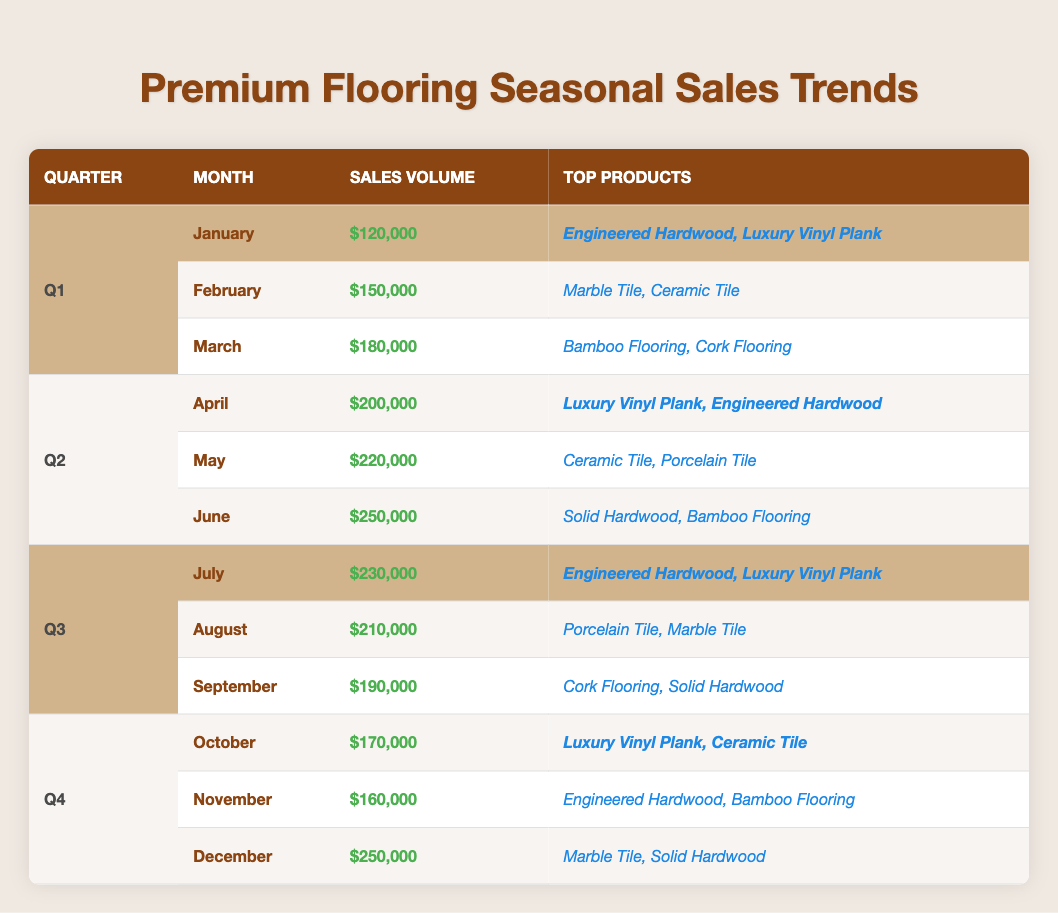What was the sales volume in June? The sales volume listed for June is $250,000, as shown directly in the table under Q2 for the month of June.
Answer: $250,000 Which month had the highest sales volume in Q1? By comparing the sales volumes of January ($120,000), February ($150,000), and March ($180,000), March has the highest sales volume of $180,000.
Answer: March What are the top products sold in October? The top products listed for October are Luxury Vinyl Plank and Ceramic Tile, as seen in the table for Q4 in the month of October.
Answer: Luxury Vinyl Plank, Ceramic Tile What is the total sales volume for Q3? Summing the sales volumes for July ($230,000), August ($210,000), and September ($190,000) gives a total of $230,000 + $210,000 + $190,000 = $630,000 for Q3.
Answer: $630,000 Were Engineered Hardwood products sold in every quarter? Looking at the top products for each quarter: Q1 has it, Q2 has it, Q3 has it, and Q4 has it too, confirming that Engineered Hardwood is present in all quarters.
Answer: Yes What was the average sales volume across all months in Q2? The sales volumes for Q2 are April ($200,000), May ($220,000), and June ($250,000). Adding these gives $200,000 + $220,000 + $250,000 = $670,000. Dividing by 3 months gives an average of $670,000 / 3 = $223,333.33, which rounds to $223,333.
Answer: $223,333 Which quarter had the highest total sales volume overall? Calculating total sales volumes: Q1 = $450,000 ($120,000 + $150,000 + $180,000), Q2 = $670,000 ($200,000 + $220,000 + $250,000), Q3 = $630,000 ($230,000 + $210,000 + $190,000), Q4 = $580,000 ($170,000 + $160,000 + $250,000). Q2 has the highest at $670,000.
Answer: Q2 How did sales volumes in December compare to those in January? The sales volume in December is $250,000, while in January it is $120,000. The difference is $250,000 - $120,000 = $130,000, indicating December's sales were significantly higher.
Answer: December's sales were higher by $130,000 